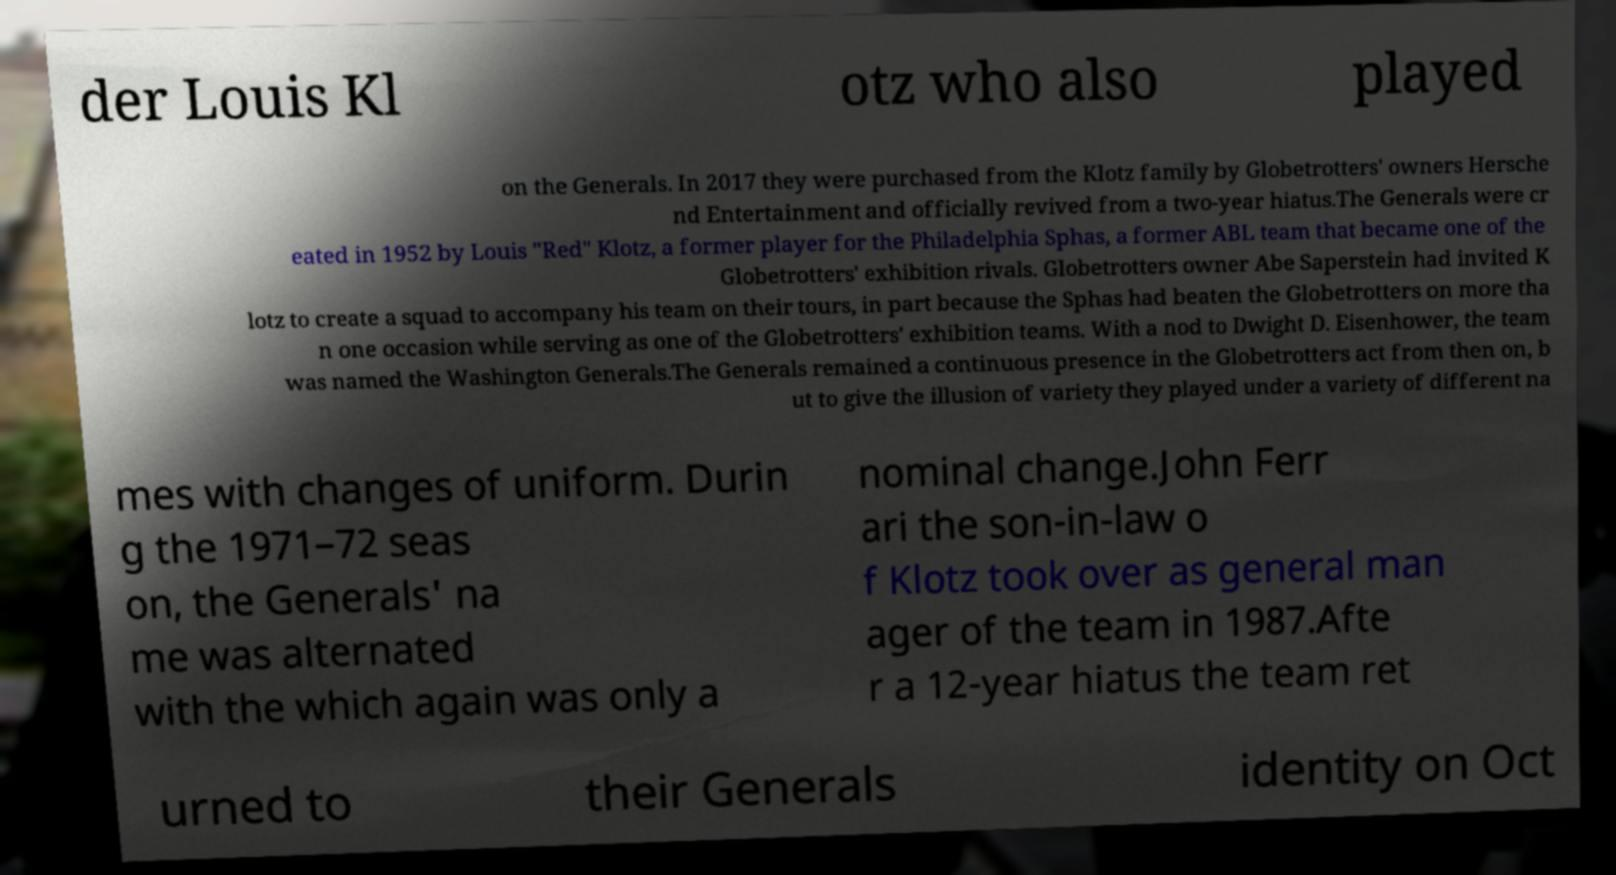What messages or text are displayed in this image? I need them in a readable, typed format. der Louis Kl otz who also played on the Generals. In 2017 they were purchased from the Klotz family by Globetrotters' owners Hersche nd Entertainment and officially revived from a two-year hiatus.The Generals were cr eated in 1952 by Louis "Red" Klotz, a former player for the Philadelphia Sphas, a former ABL team that became one of the Globetrotters' exhibition rivals. Globetrotters owner Abe Saperstein had invited K lotz to create a squad to accompany his team on their tours, in part because the Sphas had beaten the Globetrotters on more tha n one occasion while serving as one of the Globetrotters' exhibition teams. With a nod to Dwight D. Eisenhower, the team was named the Washington Generals.The Generals remained a continuous presence in the Globetrotters act from then on, b ut to give the illusion of variety they played under a variety of different na mes with changes of uniform. Durin g the 1971–72 seas on, the Generals' na me was alternated with the which again was only a nominal change.John Ferr ari the son-in-law o f Klotz took over as general man ager of the team in 1987.Afte r a 12-year hiatus the team ret urned to their Generals identity on Oct 